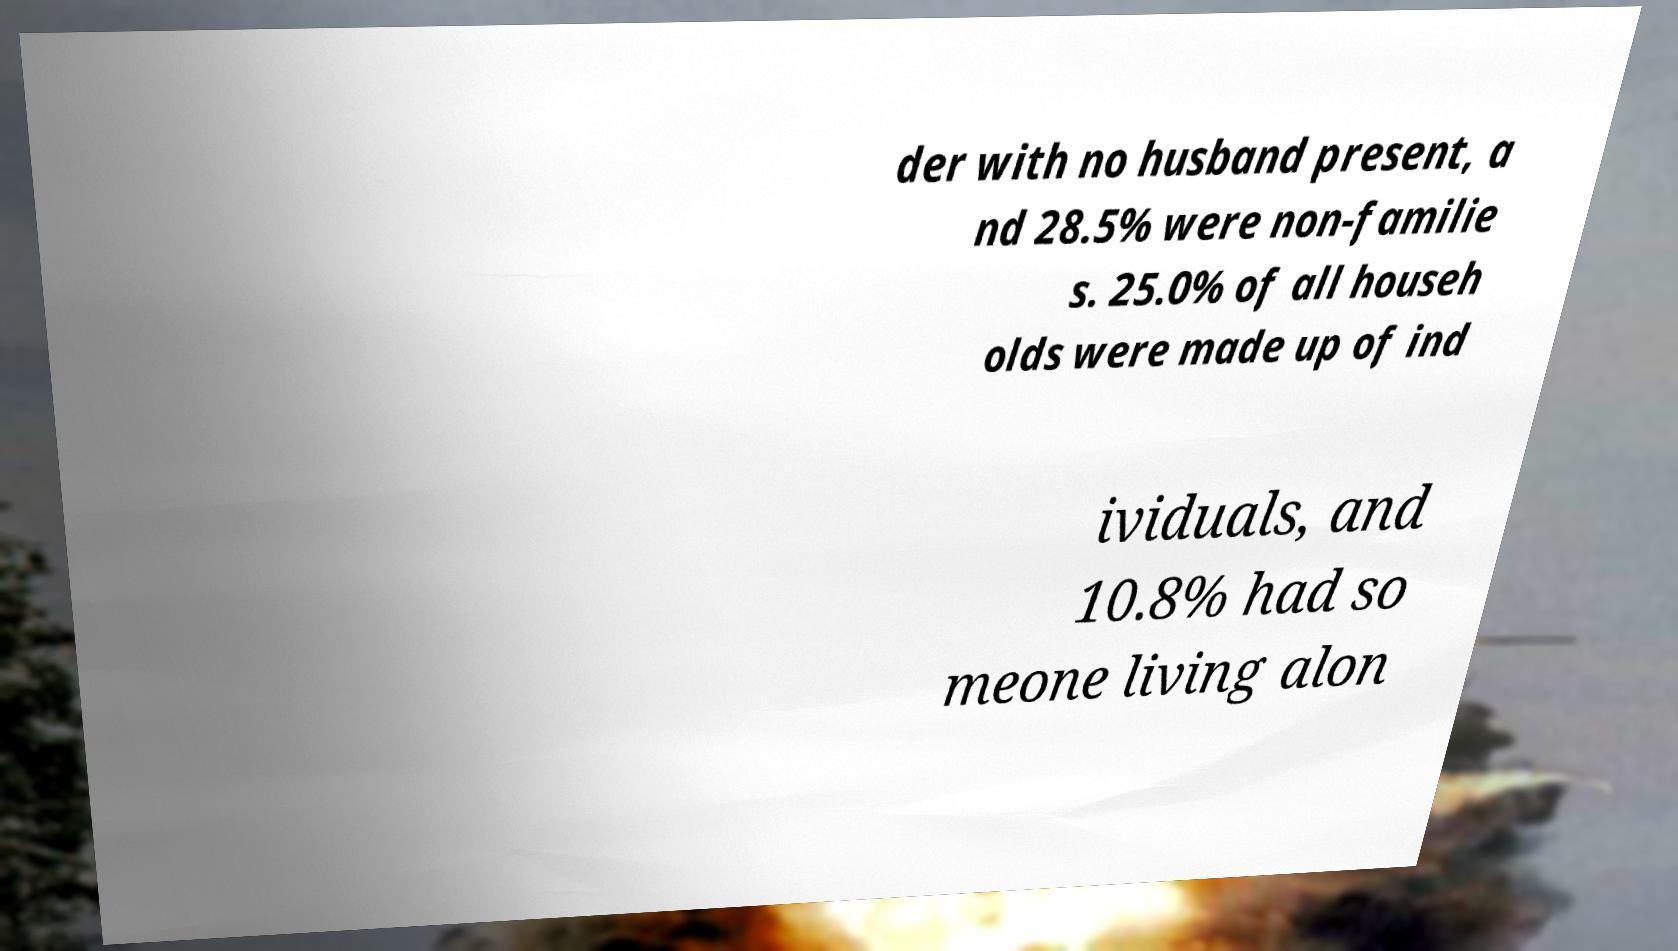Could you extract and type out the text from this image? der with no husband present, a nd 28.5% were non-familie s. 25.0% of all househ olds were made up of ind ividuals, and 10.8% had so meone living alon 